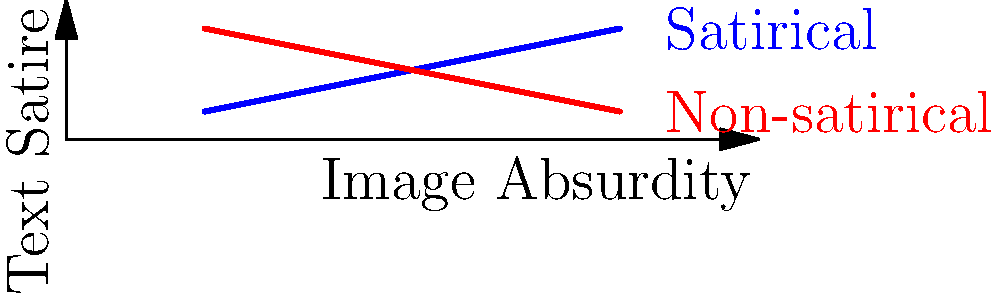In the realm of political satire, one might encounter a graph comparing "Image Absurdity" to "Text Satire" for various news headlines. If the blue line represents satirical content and the red line non-satirical, what cheeky observation might one make about the relationship between image absurdity and text satire in genuine news versus satirical pieces? To answer this question, let's analyze the graph step-by-step:

1. The x-axis represents "Image Absurdity," increasing from left to right.
2. The y-axis represents "Text Satire," increasing from bottom to top.
3. The blue line, representing satirical content, shows an upward trend.
4. The red line, representing non-satirical content, shows a downward trend.

Now, let's interpret these trends:

5. For satirical content (blue line):
   - As image absurdity increases, the level of text satire also increases.
   - This suggests that satirical news tends to pair more absurd images with more satirical text.

6. For non-satirical content (red line):
   - As image absurdity increases, the level of text satire decreases.
   - This implies that genuine news tends to use less absurd images with more straightforward text.

7. The lines intersect, indicating a point where satirical and non-satirical content might be indistinguishable.

A cheeky observation would be that as real news becomes more absurd, it actually becomes less satirical, while satirical news embraces the absurdity in both text and image.
Answer: As reality becomes stranger, satire must work harder to outdo it. 